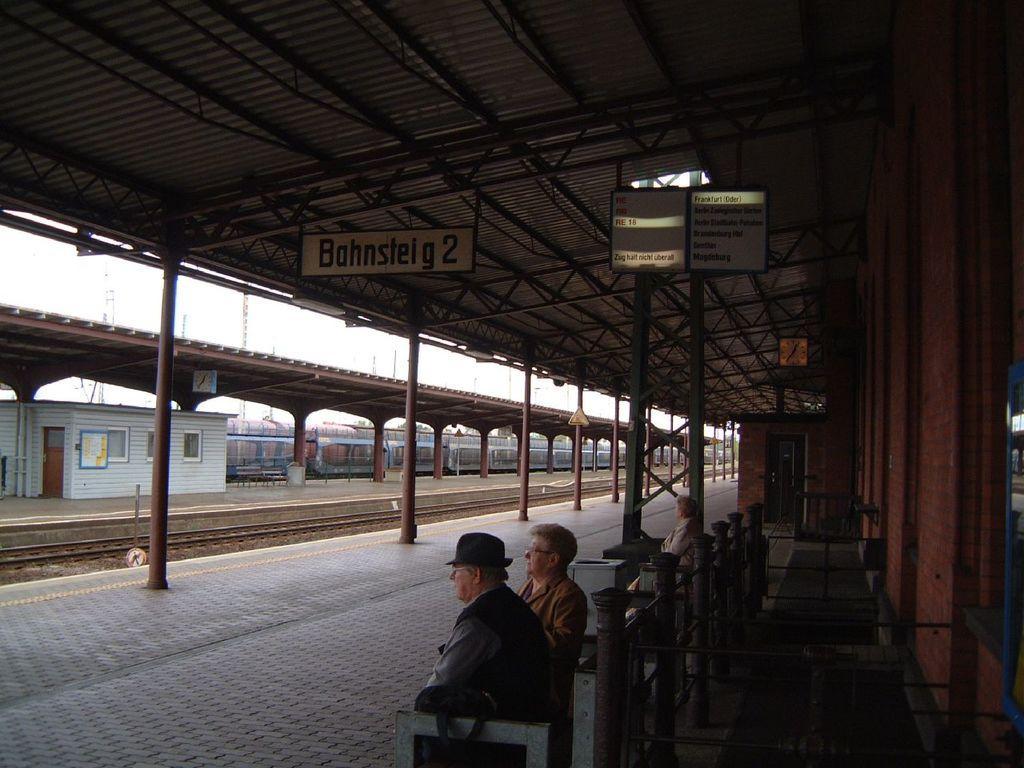Please provide a concise description of this image. In this image there are people sitting on benches on the train station platform, beside them there are trash cans, behind them there are metal rods. In front of them there, there are train tracks, behind the tracks on the platform there are metal rods and waiting rooms, behind that there is a train. At the top of the image there are display boards and sign boards on the rooftop supported by metal rods. 